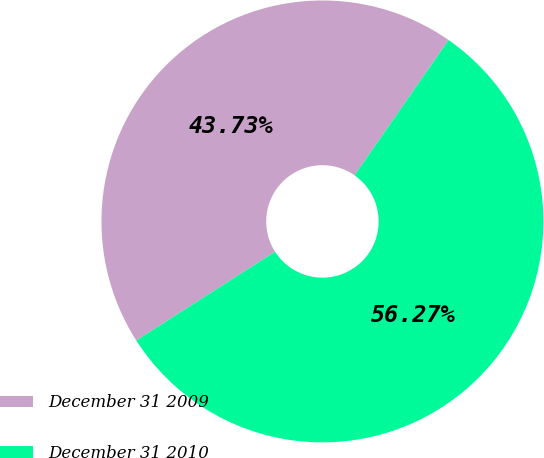Convert chart to OTSL. <chart><loc_0><loc_0><loc_500><loc_500><pie_chart><fcel>December 31 2009<fcel>December 31 2010<nl><fcel>43.73%<fcel>56.27%<nl></chart> 